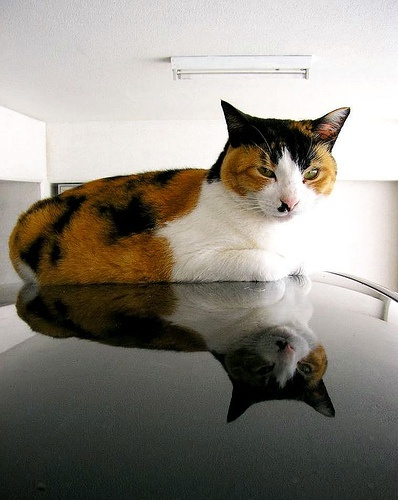Describe the objects in this image and their specific colors. I can see dining table in darkgray, black, gray, and lightgray tones and cat in darkgray, black, maroon, and white tones in this image. 